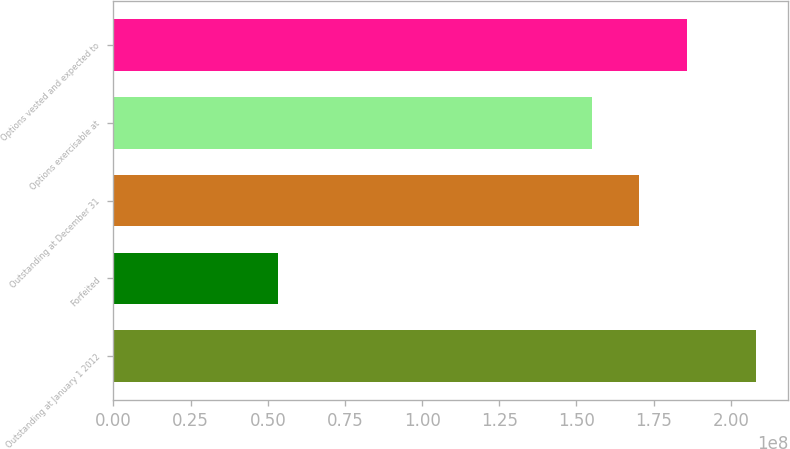Convert chart. <chart><loc_0><loc_0><loc_500><loc_500><bar_chart><fcel>Outstanding at January 1 2012<fcel>Forfeited<fcel>Outstanding at December 31<fcel>Options exercisable at<fcel>Options vested and expected to<nl><fcel>2.0827e+08<fcel>5.33459e+07<fcel>1.70415e+08<fcel>1.54923e+08<fcel>1.85907e+08<nl></chart> 